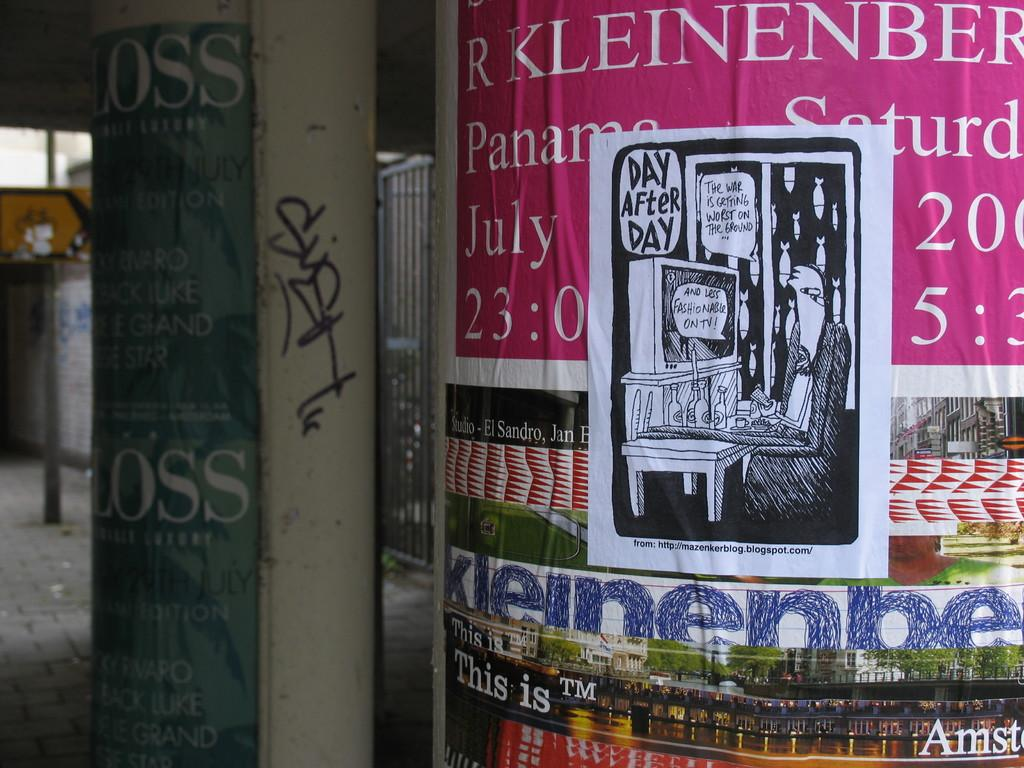Provide a one-sentence caption for the provided image. A poster for R Kleinenberg with a graffiti sticker slapped on the middle of it. 